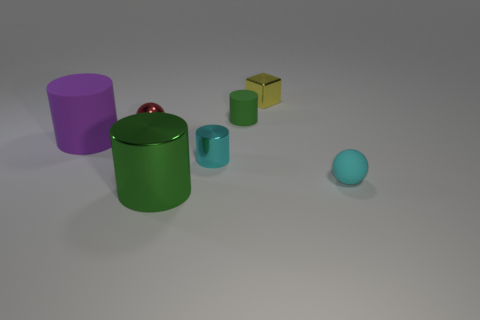Subtract all cyan metal cylinders. How many cylinders are left? 3 Add 2 tiny green cylinders. How many objects exist? 9 Subtract 3 cylinders. How many cylinders are left? 1 Subtract all green blocks. How many green cylinders are left? 2 Subtract all cyan cylinders. How many cylinders are left? 3 Subtract all cylinders. How many objects are left? 3 Add 5 small shiny balls. How many small shiny balls exist? 6 Subtract 1 red spheres. How many objects are left? 6 Subtract all blue spheres. Subtract all yellow blocks. How many spheres are left? 2 Subtract all large purple rubber things. Subtract all tiny green rubber cylinders. How many objects are left? 5 